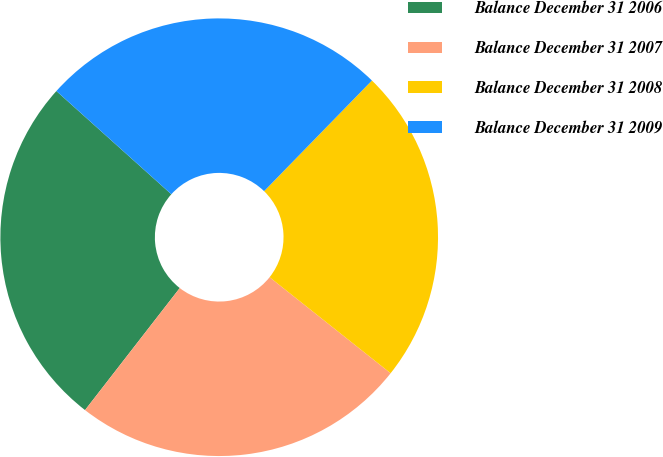Convert chart to OTSL. <chart><loc_0><loc_0><loc_500><loc_500><pie_chart><fcel>Balance December 31 2006<fcel>Balance December 31 2007<fcel>Balance December 31 2008<fcel>Balance December 31 2009<nl><fcel>26.14%<fcel>24.83%<fcel>23.38%<fcel>25.65%<nl></chart> 